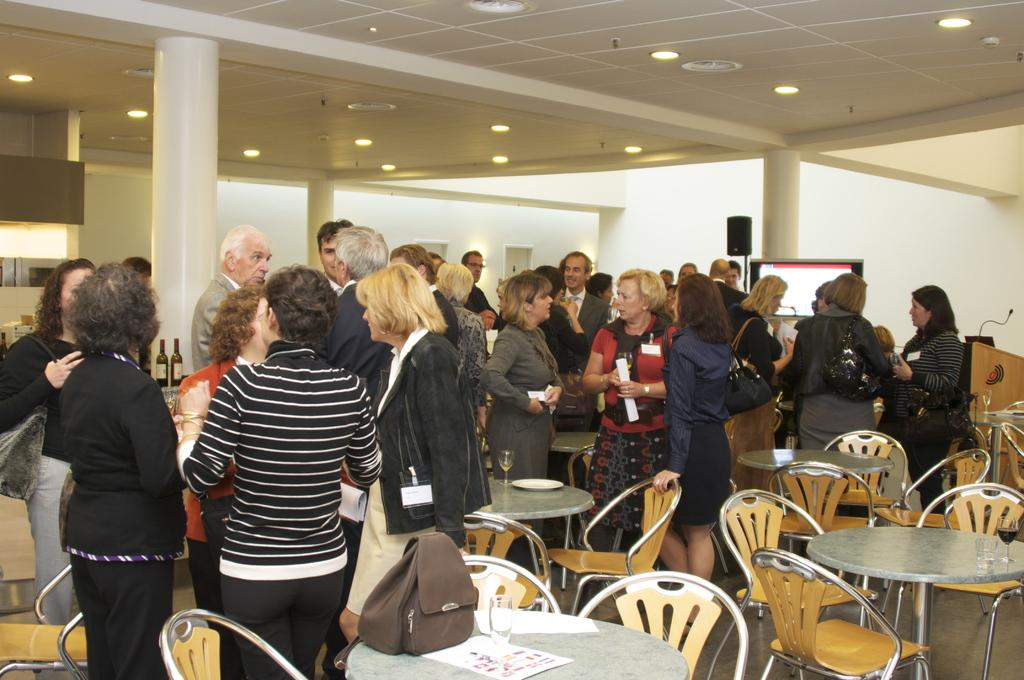What can be seen in the image in terms of human presence? There are people standing in the image. What type of furniture is visible in the image? There are chairs and tables in the image. Is there a tent set up in the image? No, there is no tent present in the image. 